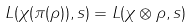Convert formula to latex. <formula><loc_0><loc_0><loc_500><loc_500>L ( \chi ( { \pi } ( \rho ) ) , s ) = L ( \chi \otimes \rho , s )</formula> 